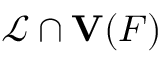<formula> <loc_0><loc_0><loc_500><loc_500>{ \mathcal { L } } \cap { V } ( F )</formula> 